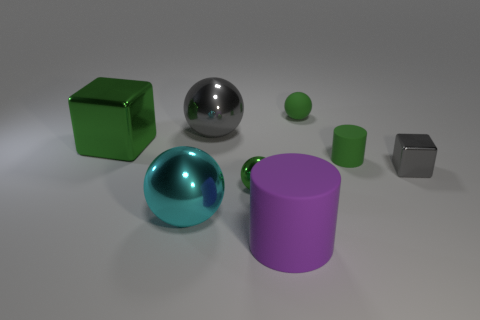Are the big object that is to the right of the gray ball and the large object that is on the left side of the big cyan thing made of the same material?
Offer a terse response. No. What material is the big thing that is both in front of the small gray metallic object and left of the purple cylinder?
Provide a succinct answer. Metal. There is a cyan shiny object; is it the same shape as the green thing in front of the tiny gray cube?
Ensure brevity in your answer.  Yes. There is a gray thing that is to the left of the metallic block in front of the big object to the left of the cyan shiny object; what is it made of?
Your answer should be compact. Metal. How many other objects are there of the same size as the green block?
Ensure brevity in your answer.  3. Is the color of the tiny cylinder the same as the large cube?
Your response must be concise. Yes. What number of small green matte cylinders are behind the tiny green object left of the green ball that is behind the large cube?
Keep it short and to the point. 1. What is the material of the big object that is on the right side of the small green ball that is in front of the tiny cube?
Offer a very short reply. Rubber. Are there any green matte objects that have the same shape as the large green shiny thing?
Give a very brief answer. No. There is a block that is the same size as the cyan shiny object; what color is it?
Provide a short and direct response. Green. 